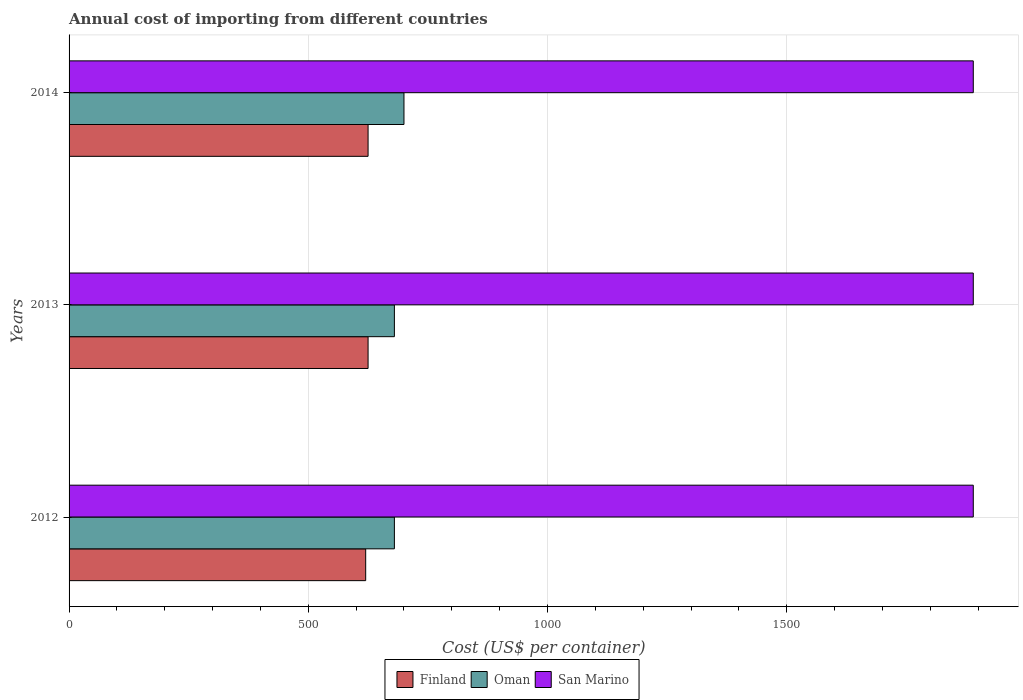Are the number of bars per tick equal to the number of legend labels?
Make the answer very short. Yes. Are the number of bars on each tick of the Y-axis equal?
Your response must be concise. Yes. What is the total annual cost of importing in San Marino in 2014?
Provide a short and direct response. 1890. Across all years, what is the maximum total annual cost of importing in Oman?
Offer a terse response. 700. Across all years, what is the minimum total annual cost of importing in San Marino?
Your response must be concise. 1890. In which year was the total annual cost of importing in Finland maximum?
Provide a short and direct response. 2013. What is the total total annual cost of importing in Finland in the graph?
Ensure brevity in your answer.  1870. What is the difference between the total annual cost of importing in Oman in 2013 and the total annual cost of importing in San Marino in 2012?
Your response must be concise. -1210. What is the average total annual cost of importing in San Marino per year?
Provide a short and direct response. 1890. In the year 2012, what is the difference between the total annual cost of importing in Oman and total annual cost of importing in San Marino?
Make the answer very short. -1210. What is the difference between the highest and the lowest total annual cost of importing in Oman?
Offer a very short reply. 20. In how many years, is the total annual cost of importing in Oman greater than the average total annual cost of importing in Oman taken over all years?
Offer a very short reply. 1. Is the sum of the total annual cost of importing in Oman in 2013 and 2014 greater than the maximum total annual cost of importing in Finland across all years?
Your answer should be very brief. Yes. What does the 2nd bar from the bottom in 2013 represents?
Make the answer very short. Oman. How many bars are there?
Offer a terse response. 9. Does the graph contain any zero values?
Ensure brevity in your answer.  No. How many legend labels are there?
Your answer should be very brief. 3. How are the legend labels stacked?
Your answer should be compact. Horizontal. What is the title of the graph?
Make the answer very short. Annual cost of importing from different countries. What is the label or title of the X-axis?
Offer a very short reply. Cost (US$ per container). What is the Cost (US$ per container) in Finland in 2012?
Give a very brief answer. 620. What is the Cost (US$ per container) of Oman in 2012?
Your answer should be very brief. 680. What is the Cost (US$ per container) in San Marino in 2012?
Make the answer very short. 1890. What is the Cost (US$ per container) of Finland in 2013?
Offer a very short reply. 625. What is the Cost (US$ per container) of Oman in 2013?
Your response must be concise. 680. What is the Cost (US$ per container) in San Marino in 2013?
Provide a short and direct response. 1890. What is the Cost (US$ per container) in Finland in 2014?
Make the answer very short. 625. What is the Cost (US$ per container) in Oman in 2014?
Make the answer very short. 700. What is the Cost (US$ per container) of San Marino in 2014?
Provide a succinct answer. 1890. Across all years, what is the maximum Cost (US$ per container) in Finland?
Your response must be concise. 625. Across all years, what is the maximum Cost (US$ per container) of Oman?
Offer a terse response. 700. Across all years, what is the maximum Cost (US$ per container) of San Marino?
Ensure brevity in your answer.  1890. Across all years, what is the minimum Cost (US$ per container) in Finland?
Your response must be concise. 620. Across all years, what is the minimum Cost (US$ per container) in Oman?
Keep it short and to the point. 680. Across all years, what is the minimum Cost (US$ per container) in San Marino?
Your answer should be very brief. 1890. What is the total Cost (US$ per container) in Finland in the graph?
Provide a short and direct response. 1870. What is the total Cost (US$ per container) in Oman in the graph?
Your answer should be compact. 2060. What is the total Cost (US$ per container) in San Marino in the graph?
Your answer should be very brief. 5670. What is the difference between the Cost (US$ per container) of Finland in 2012 and that in 2013?
Your answer should be compact. -5. What is the difference between the Cost (US$ per container) in San Marino in 2012 and that in 2013?
Your response must be concise. 0. What is the difference between the Cost (US$ per container) in Finland in 2012 and that in 2014?
Give a very brief answer. -5. What is the difference between the Cost (US$ per container) of Oman in 2012 and that in 2014?
Provide a succinct answer. -20. What is the difference between the Cost (US$ per container) in Finland in 2012 and the Cost (US$ per container) in Oman in 2013?
Offer a very short reply. -60. What is the difference between the Cost (US$ per container) of Finland in 2012 and the Cost (US$ per container) of San Marino in 2013?
Ensure brevity in your answer.  -1270. What is the difference between the Cost (US$ per container) in Oman in 2012 and the Cost (US$ per container) in San Marino in 2013?
Make the answer very short. -1210. What is the difference between the Cost (US$ per container) of Finland in 2012 and the Cost (US$ per container) of Oman in 2014?
Your response must be concise. -80. What is the difference between the Cost (US$ per container) in Finland in 2012 and the Cost (US$ per container) in San Marino in 2014?
Make the answer very short. -1270. What is the difference between the Cost (US$ per container) in Oman in 2012 and the Cost (US$ per container) in San Marino in 2014?
Offer a very short reply. -1210. What is the difference between the Cost (US$ per container) in Finland in 2013 and the Cost (US$ per container) in Oman in 2014?
Your answer should be compact. -75. What is the difference between the Cost (US$ per container) of Finland in 2013 and the Cost (US$ per container) of San Marino in 2014?
Your response must be concise. -1265. What is the difference between the Cost (US$ per container) of Oman in 2013 and the Cost (US$ per container) of San Marino in 2014?
Make the answer very short. -1210. What is the average Cost (US$ per container) of Finland per year?
Offer a very short reply. 623.33. What is the average Cost (US$ per container) of Oman per year?
Ensure brevity in your answer.  686.67. What is the average Cost (US$ per container) of San Marino per year?
Ensure brevity in your answer.  1890. In the year 2012, what is the difference between the Cost (US$ per container) in Finland and Cost (US$ per container) in Oman?
Offer a very short reply. -60. In the year 2012, what is the difference between the Cost (US$ per container) in Finland and Cost (US$ per container) in San Marino?
Keep it short and to the point. -1270. In the year 2012, what is the difference between the Cost (US$ per container) in Oman and Cost (US$ per container) in San Marino?
Provide a short and direct response. -1210. In the year 2013, what is the difference between the Cost (US$ per container) in Finland and Cost (US$ per container) in Oman?
Your answer should be compact. -55. In the year 2013, what is the difference between the Cost (US$ per container) of Finland and Cost (US$ per container) of San Marino?
Give a very brief answer. -1265. In the year 2013, what is the difference between the Cost (US$ per container) in Oman and Cost (US$ per container) in San Marino?
Provide a short and direct response. -1210. In the year 2014, what is the difference between the Cost (US$ per container) of Finland and Cost (US$ per container) of Oman?
Your response must be concise. -75. In the year 2014, what is the difference between the Cost (US$ per container) in Finland and Cost (US$ per container) in San Marino?
Offer a terse response. -1265. In the year 2014, what is the difference between the Cost (US$ per container) in Oman and Cost (US$ per container) in San Marino?
Keep it short and to the point. -1190. What is the ratio of the Cost (US$ per container) in Oman in 2012 to that in 2013?
Give a very brief answer. 1. What is the ratio of the Cost (US$ per container) in Oman in 2012 to that in 2014?
Offer a very short reply. 0.97. What is the ratio of the Cost (US$ per container) of San Marino in 2012 to that in 2014?
Offer a very short reply. 1. What is the ratio of the Cost (US$ per container) of Oman in 2013 to that in 2014?
Ensure brevity in your answer.  0.97. What is the ratio of the Cost (US$ per container) of San Marino in 2013 to that in 2014?
Your answer should be very brief. 1. What is the difference between the highest and the second highest Cost (US$ per container) of Finland?
Provide a short and direct response. 0. What is the difference between the highest and the second highest Cost (US$ per container) of Oman?
Your answer should be compact. 20. What is the difference between the highest and the second highest Cost (US$ per container) of San Marino?
Provide a succinct answer. 0. What is the difference between the highest and the lowest Cost (US$ per container) of San Marino?
Your answer should be compact. 0. 